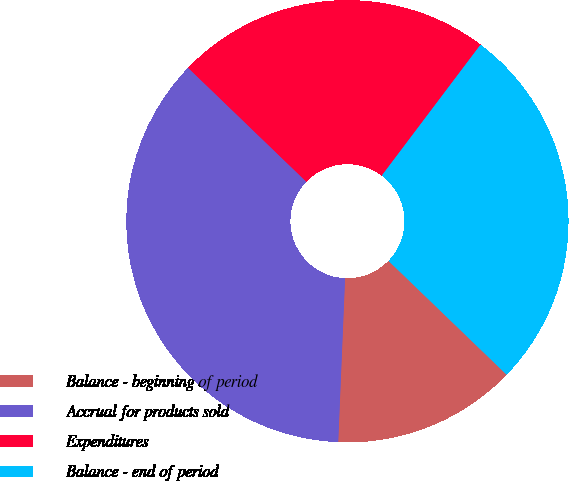<chart> <loc_0><loc_0><loc_500><loc_500><pie_chart><fcel>Balance - beginning of period<fcel>Accrual for products sold<fcel>Expenditures<fcel>Balance - end of period<nl><fcel>13.46%<fcel>36.54%<fcel>23.08%<fcel>26.92%<nl></chart> 